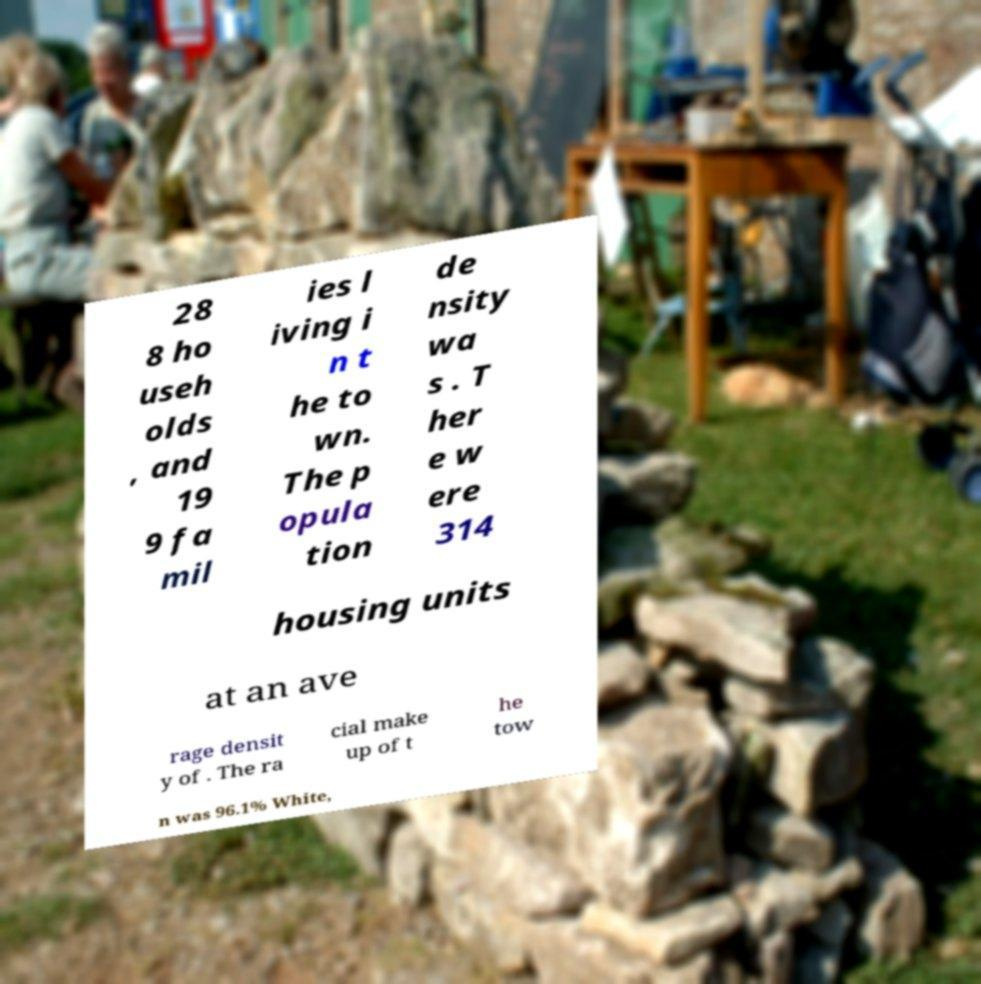What messages or text are displayed in this image? I need them in a readable, typed format. 28 8 ho useh olds , and 19 9 fa mil ies l iving i n t he to wn. The p opula tion de nsity wa s . T her e w ere 314 housing units at an ave rage densit y of . The ra cial make up of t he tow n was 96.1% White, 